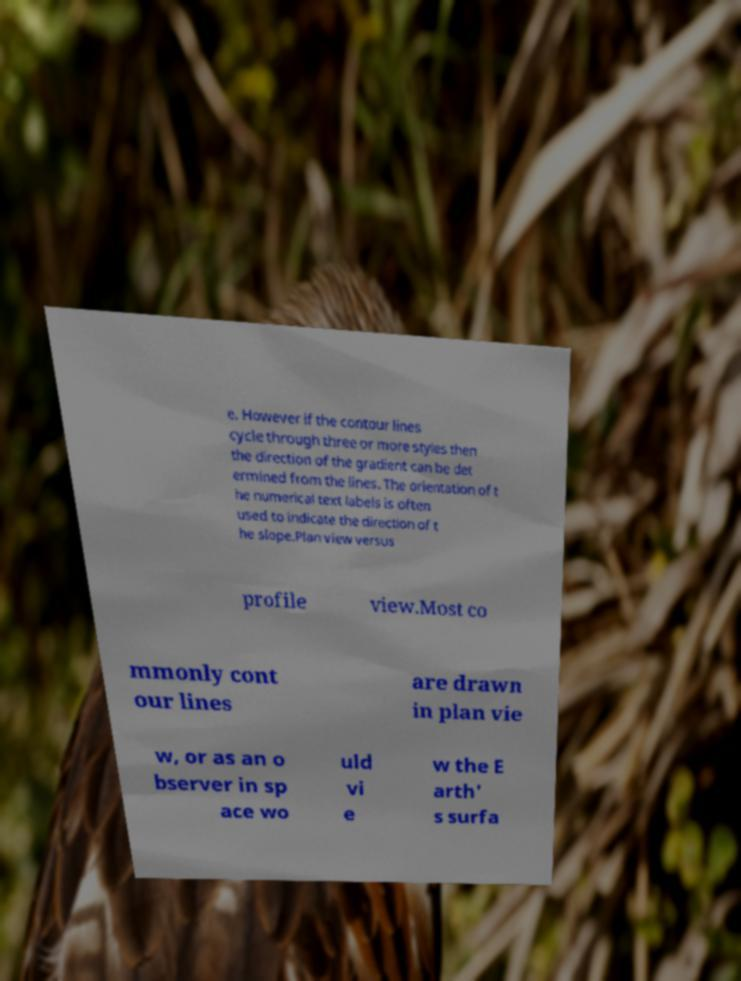Can you accurately transcribe the text from the provided image for me? e. However if the contour lines cycle through three or more styles then the direction of the gradient can be det ermined from the lines. The orientation of t he numerical text labels is often used to indicate the direction of t he slope.Plan view versus profile view.Most co mmonly cont our lines are drawn in plan vie w, or as an o bserver in sp ace wo uld vi e w the E arth' s surfa 